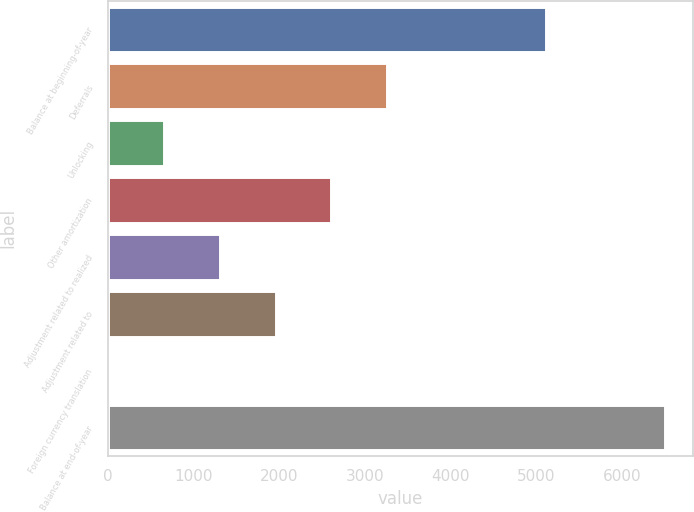Convert chart to OTSL. <chart><loc_0><loc_0><loc_500><loc_500><bar_chart><fcel>Balance at beginning-of-year<fcel>Deferrals<fcel>Unlocking<fcel>Other amortization<fcel>Adjustment related to realized<fcel>Adjustment related to<fcel>Foreign currency translation<fcel>Balance at end-of-year<nl><fcel>5116<fcel>3259<fcel>658.2<fcel>2608.8<fcel>1308.4<fcel>1958.6<fcel>8<fcel>6510<nl></chart> 